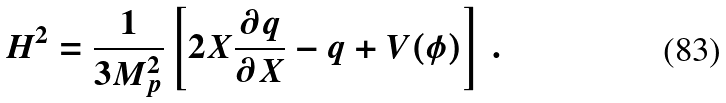<formula> <loc_0><loc_0><loc_500><loc_500>H ^ { 2 } = \frac { 1 } { 3 M _ { p } ^ { 2 } } \left [ 2 X \frac { \partial q } { \partial X } - q + V ( \phi ) \right ] \, .</formula> 